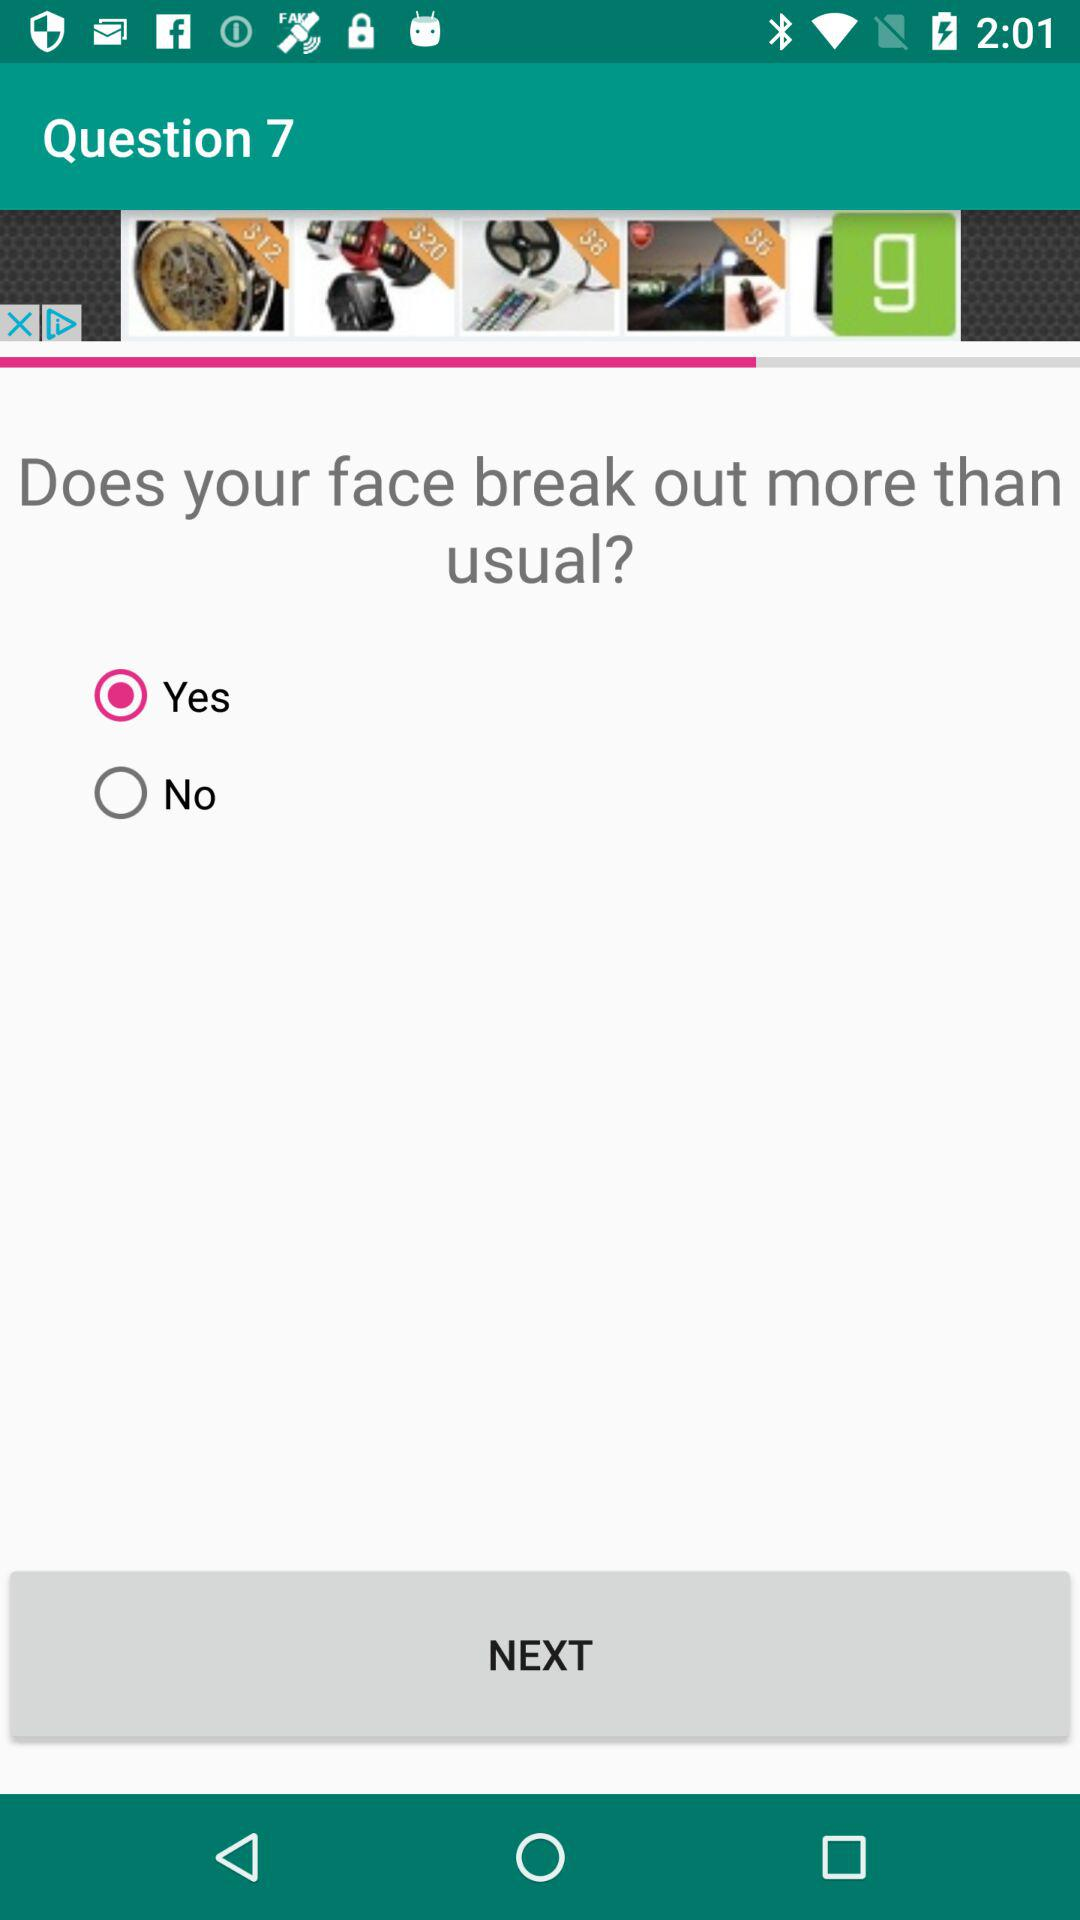What question number is this? This is question number 7. 